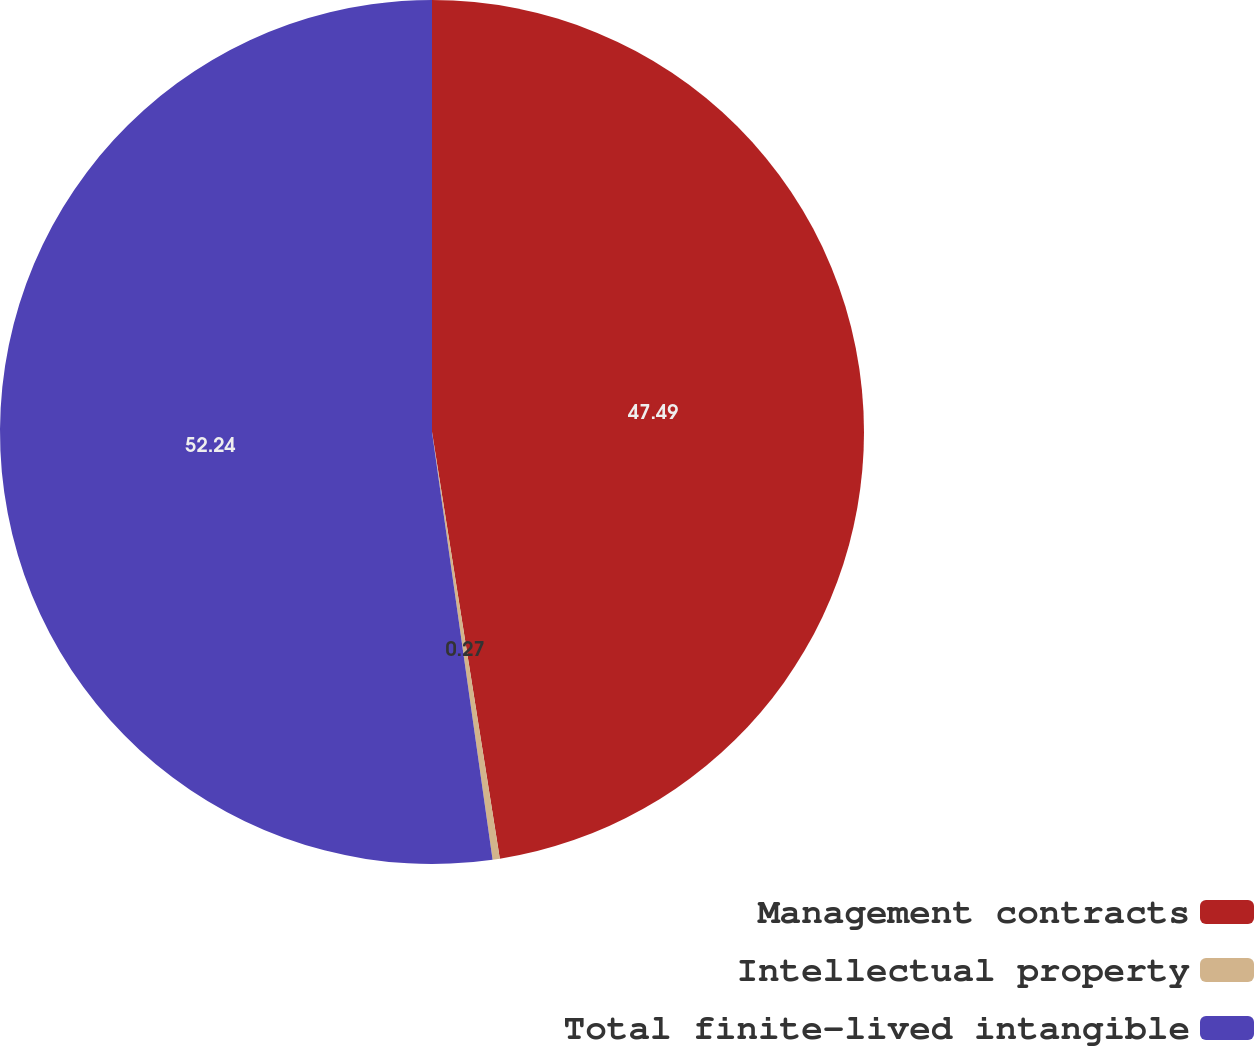<chart> <loc_0><loc_0><loc_500><loc_500><pie_chart><fcel>Management contracts<fcel>Intellectual property<fcel>Total finite-lived intangible<nl><fcel>47.49%<fcel>0.27%<fcel>52.24%<nl></chart> 